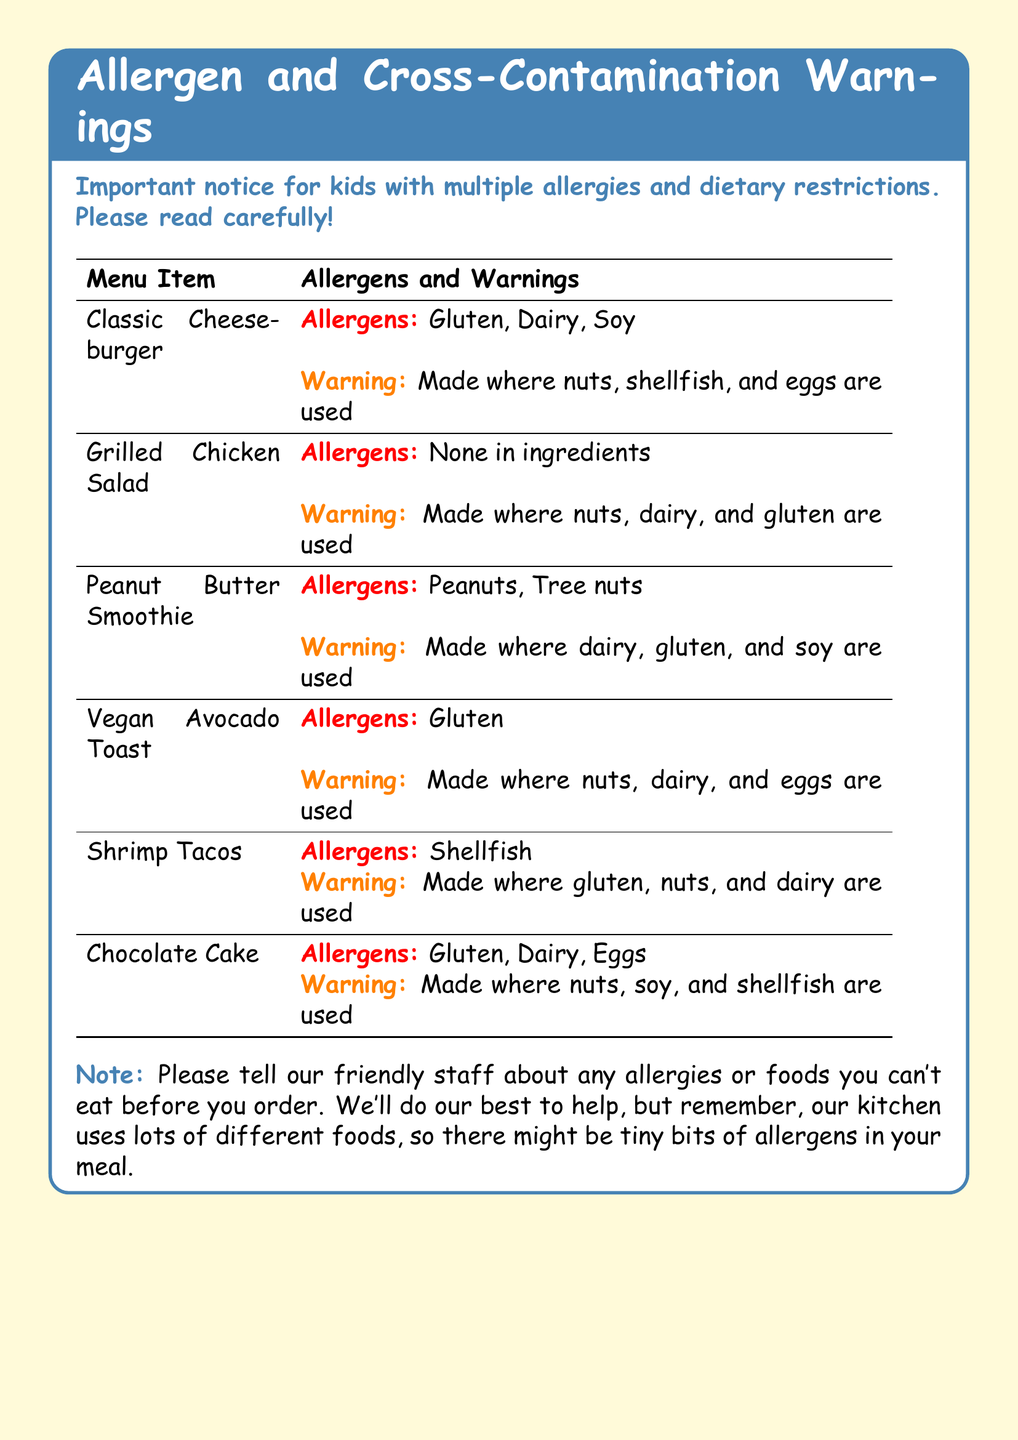What allergens are in the Classic Cheeseburger? The allergens listed for the Classic Cheeseburger are Gluten, Dairy, Soy.
Answer: Gluten, Dairy, Soy What is the warning for the Grilled Chicken Salad? The warning states that it is made where nuts, dairy, and gluten are used.
Answer: Made where nuts, dairy, and gluten are used Which menu item contains shellfish? The menu item listed with shellfish is Shrimp Tacos.
Answer: Shrimp Tacos How many allergens are listed for the Vegan Avocado Toast? The Vegan Avocado Toast has one allergen listed, which is Gluten.
Answer: Gluten What should you do before ordering? The note advises to tell the staff about any allergies or foods that cannot be eaten before ordering.
Answer: Tell the staff about any allergies What is the main allergen in the Peanut Butter Smoothie? The main allergens in the Peanut Butter Smoothie are Peanuts and Tree nuts.
Answer: Peanuts, Tree nuts 